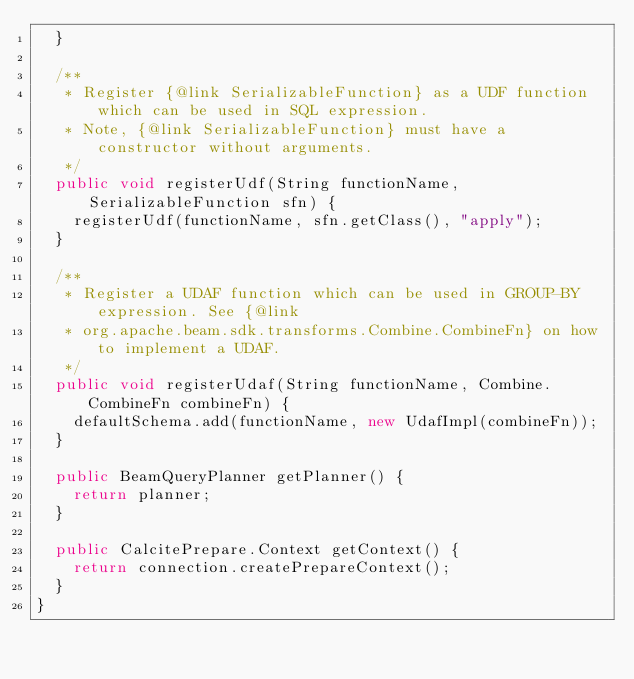Convert code to text. <code><loc_0><loc_0><loc_500><loc_500><_Java_>  }

  /**
   * Register {@link SerializableFunction} as a UDF function which can be used in SQL expression.
   * Note, {@link SerializableFunction} must have a constructor without arguments.
   */
  public void registerUdf(String functionName, SerializableFunction sfn) {
    registerUdf(functionName, sfn.getClass(), "apply");
  }

  /**
   * Register a UDAF function which can be used in GROUP-BY expression. See {@link
   * org.apache.beam.sdk.transforms.Combine.CombineFn} on how to implement a UDAF.
   */
  public void registerUdaf(String functionName, Combine.CombineFn combineFn) {
    defaultSchema.add(functionName, new UdafImpl(combineFn));
  }

  public BeamQueryPlanner getPlanner() {
    return planner;
  }

  public CalcitePrepare.Context getContext() {
    return connection.createPrepareContext();
  }
}
</code> 